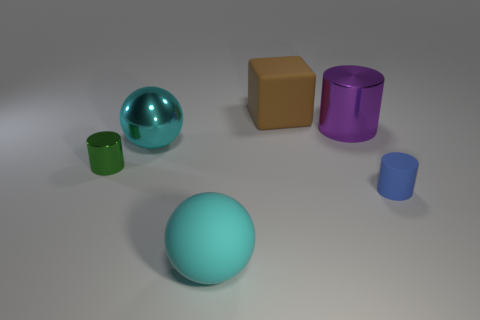Add 2 green cylinders. How many objects exist? 8 Subtract all spheres. How many objects are left? 4 Add 1 yellow rubber balls. How many yellow rubber balls exist? 1 Subtract 0 yellow cylinders. How many objects are left? 6 Subtract all purple metallic things. Subtract all big metal spheres. How many objects are left? 4 Add 6 large matte spheres. How many large matte spheres are left? 7 